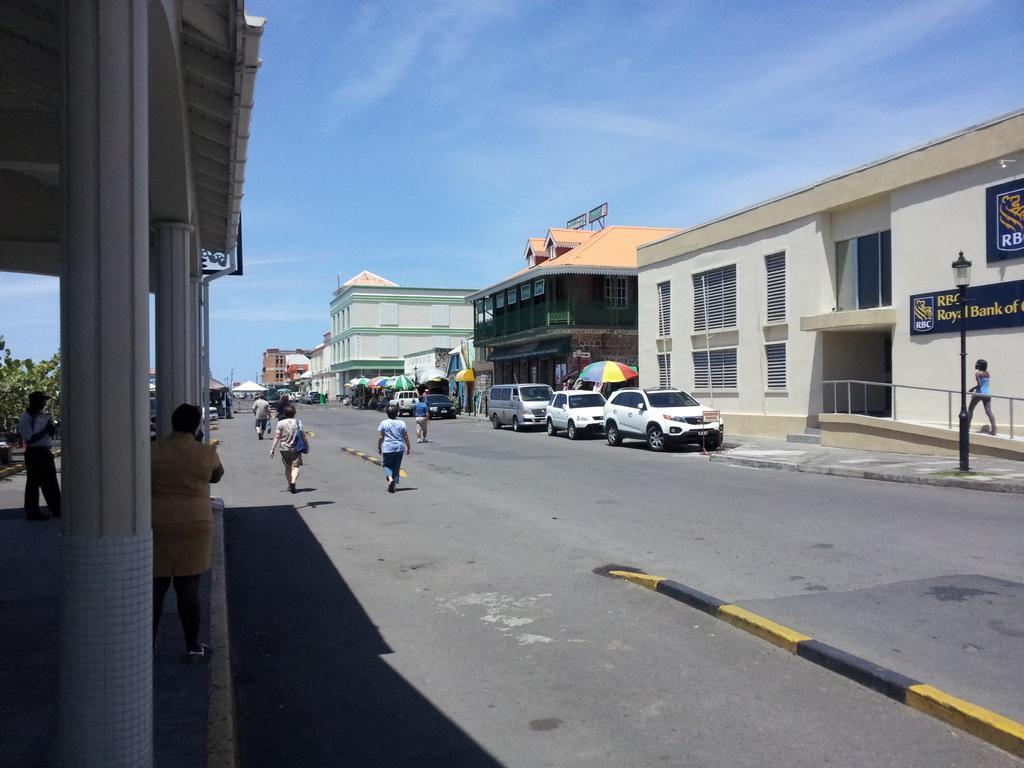In one or two sentences, can you explain what this image depicts? This is the picture of a city. In this image there are group of people walking and there are vehicles on the road. At the back there are buildings and trees and there are umbrellas on the footpath. On the right side of the image there is a pole and there are hoardings on the building and there is a text on the hoardings. At the top there is sky. At the bottom there is a road. 